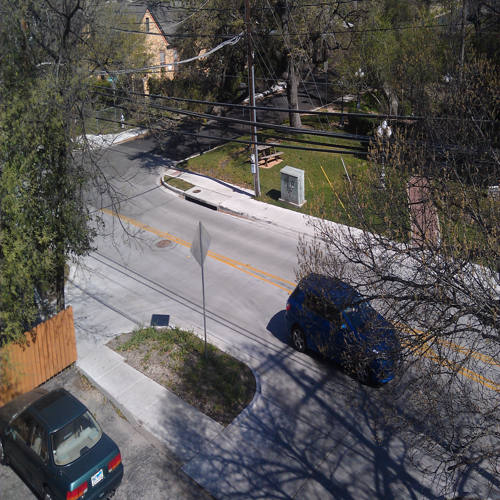What are some notable features about the area depicted in the image? The image showcases a suburban area with a quiet street. Notable features include residential homes with distinct architectural styles, a variety of trees and shrubbery, and cars parked along the side of the road indicating local residents. The presence of a utility box and stop sign suggests regulation of traffic and provision of local amenities. 